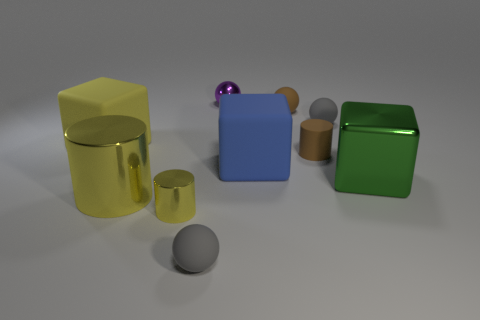How many other matte cylinders have the same color as the tiny matte cylinder?
Offer a very short reply. 0. Are there any gray balls on the right side of the purple metal thing?
Offer a terse response. Yes. Are there the same number of big yellow metallic things that are right of the big blue block and gray rubber balls that are right of the large cylinder?
Give a very brief answer. No. There is a gray matte sphere that is on the left side of the tiny metallic ball; is its size the same as the cylinder right of the blue thing?
Keep it short and to the point. Yes. There is a tiny shiny object that is right of the small rubber thing that is in front of the tiny shiny object in front of the matte cylinder; what is its shape?
Your answer should be compact. Sphere. Are there any other things that are made of the same material as the purple sphere?
Offer a terse response. Yes. The green metal thing that is the same shape as the yellow matte thing is what size?
Keep it short and to the point. Large. The cylinder that is to the right of the big cylinder and behind the tiny yellow cylinder is what color?
Your answer should be compact. Brown. Are the purple ball and the small gray thing right of the shiny ball made of the same material?
Provide a short and direct response. No. Is the number of small metallic objects behind the yellow rubber thing less than the number of brown metallic cylinders?
Your answer should be very brief. No. 